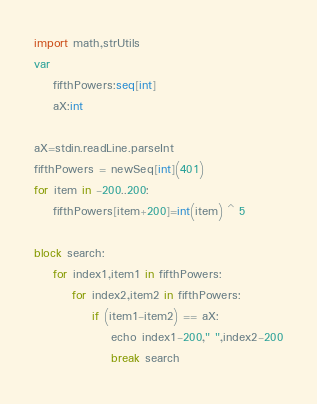Convert code to text. <code><loc_0><loc_0><loc_500><loc_500><_Nim_>import math,strUtils
var 
    fifthPowers:seq[int]
    aX:int

aX=stdin.readLine.parseInt
fifthPowers = newSeq[int](401)
for item in -200..200:
    fifthPowers[item+200]=int(item) ^ 5

block search:
    for index1,item1 in fifthPowers:
        for index2,item2 in fifthPowers:
            if (item1-item2) == aX:
                echo index1-200," ",index2-200
                break search</code> 